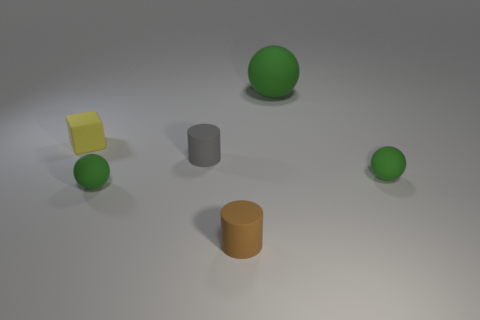Is there anything else that has the same size as the brown rubber thing?
Make the answer very short. Yes. What is the color of the tiny thing right of the green rubber object behind the cube?
Make the answer very short. Green. There is a tiny brown matte object in front of the small cylinder that is behind the green rubber thing on the left side of the brown cylinder; what shape is it?
Offer a terse response. Cylinder. How big is the object that is both to the right of the brown rubber cylinder and in front of the tiny yellow matte thing?
Offer a very short reply. Small. How many cylinders have the same color as the large thing?
Your response must be concise. 0. What material is the small yellow thing?
Provide a succinct answer. Rubber. Does the object behind the yellow rubber cube have the same material as the tiny brown cylinder?
Provide a succinct answer. Yes. The green rubber object behind the small matte cube has what shape?
Provide a succinct answer. Sphere. There is a yellow block that is the same size as the brown matte cylinder; what is it made of?
Make the answer very short. Rubber. How many things are rubber objects on the right side of the small yellow object or small rubber things in front of the yellow matte thing?
Offer a very short reply. 5. 